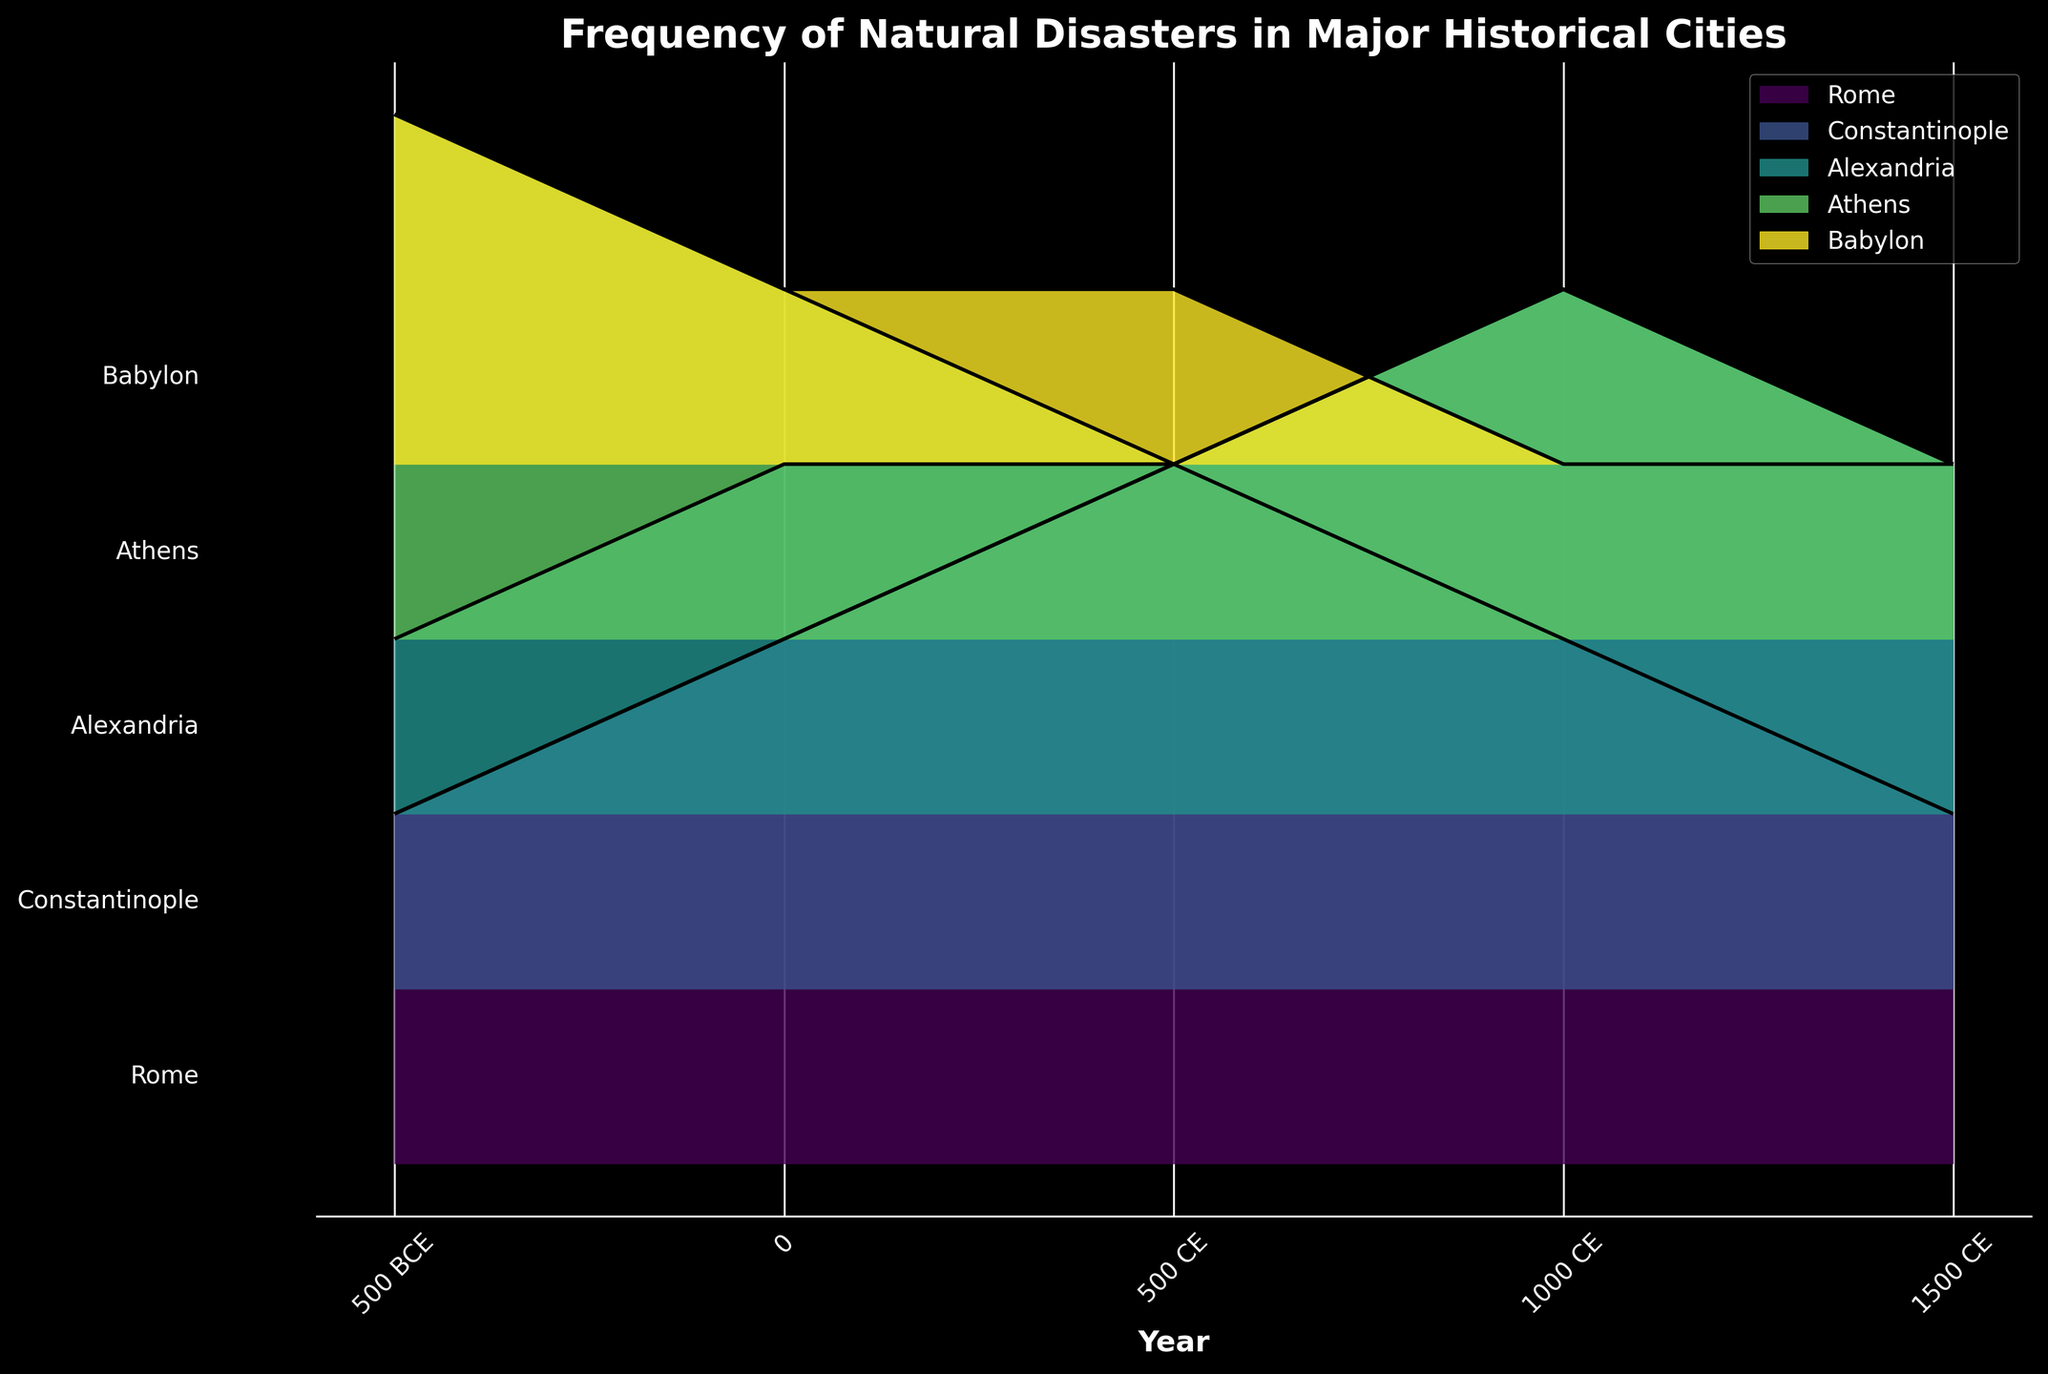What's the title of the figure? The title is usually prominently displayed at the top of a plot. In this case, the title can be found as "Frequency of Natural Disasters in Major Historical Cities."
Answer: Frequency of Natural Disasters in Major Historical Cities What time periods are represented on the x-axis? The x-axis labels represent different time periods between 500 BCE and 1500 CE. The labels are displayed at intervals of 500 years: 500 BCE, 0, 500 CE, 1000 CE, and 1500 CE.
Answer: 500 BCE, 0, 500 CE, 1000 CE, 1500 CE For which city is the frequency of natural disasters highest in 1000 CE? To determine this, examine the ridgelines at the x-axis point corresponding to 1000 CE. The city with the highest frequency (y-value) at this point is used. Constantinople has the highest disaster frequency at 1000 CE.
Answer: Constantinople How does Rome's disaster frequency compare between 500 BCE and 1000 CE? To compare, look at the ridgeline segment for Rome. In 500 BCE, the frequency is 2, and in 1000 CE, it is 3. The frequency increased from 500 BCE to 1000 CE.
Answer: Increased by 1 Which city has the lowest natural disaster frequency in 500 CE? By examining the ridgelines at the 500 CE mark, identify the city with the lowest peak. Babylon and Athens both have a disaster frequency of 1 in 500 CE.
Answer: Babylon and Athens What is the average disaster frequency in Rome from 500 BCE to 1500 CE? List the frequencies for Rome: 500 BCE (2), 0 (3), 500 CE (4), 1000 CE (3), 1500 CE (2). Sum these values (2+3+4+3+2=14) and divide by the number of periods (5): 14/5 = 2.8.
Answer: 2.8 Between 0 and 500 CE, which city's disaster frequency increased the most? Compare the frequency change between the two periods for each city. The differences are: Rome (1), Constantinople (1), Alexandria (0), Athens (-1), Babylon (0). The largest increase is for Rome and Constantinople.
Answer: Rome and Constantinople How many cities experienced a reduction in disaster frequency from 1000 CE to 1500 CE? Compare disaster frequencies for each city between 1000 CE and 1500 CE. Counts are: Rome (3 to 2), Constantinople (4 to 3), Alexandria (3 to 2), Athens (2 to 1), Babylon (0 to 0). All cities except Babylon experienced a reduction.
Answer: 4 Does any city maintain the same disaster frequency in successive time periods? Check each city for periods with no change in disaster frequency. Rome (never), Constantinople (500 BCE to 0), Alexandria (0 to 500 CE, 1500 CE), Athens (500 CE to 1000 CE, 1500 CE), Babylon (1000 CE to 1500 CE).
Answer: Constantinople, Alexandria, Athens, Babylon In general, which city appears to have the most consistent disaster frequency over time? Assess the frequency variation for each city across all periods. Babylon shows minimal changes, with frequencies decreasing and stabilizing at 0 for the last two periods.
Answer: Babylon 